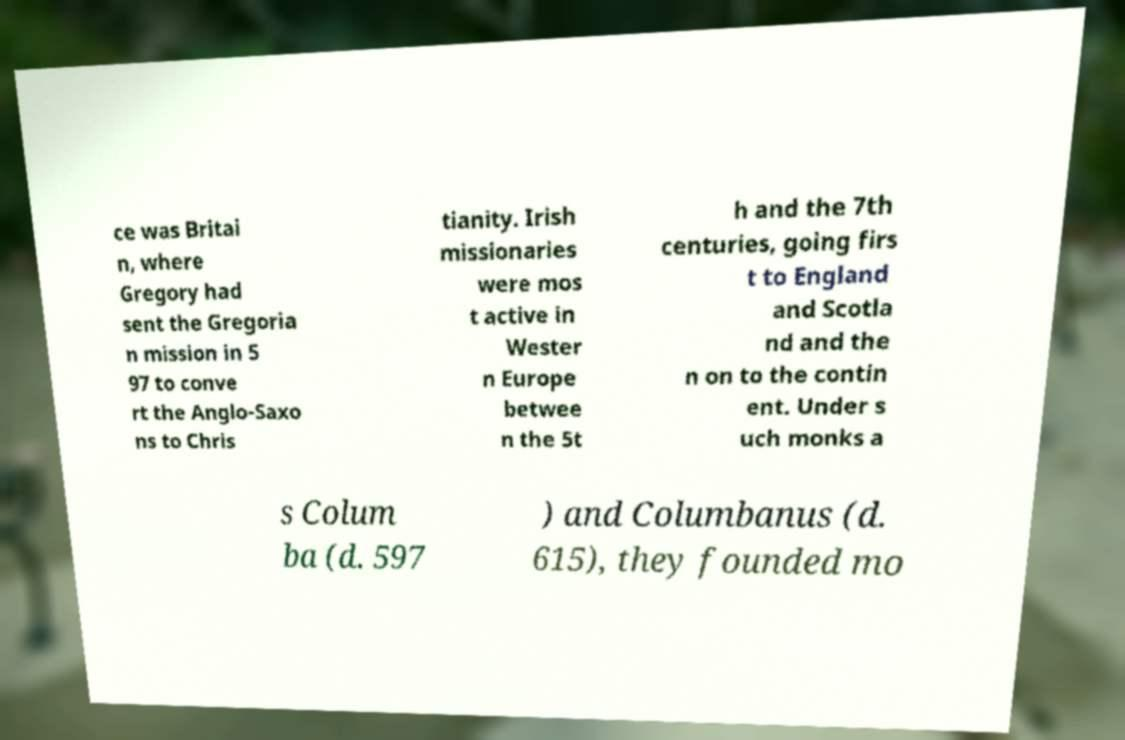Can you read and provide the text displayed in the image?This photo seems to have some interesting text. Can you extract and type it out for me? ce was Britai n, where Gregory had sent the Gregoria n mission in 5 97 to conve rt the Anglo-Saxo ns to Chris tianity. Irish missionaries were mos t active in Wester n Europe betwee n the 5t h and the 7th centuries, going firs t to England and Scotla nd and the n on to the contin ent. Under s uch monks a s Colum ba (d. 597 ) and Columbanus (d. 615), they founded mo 